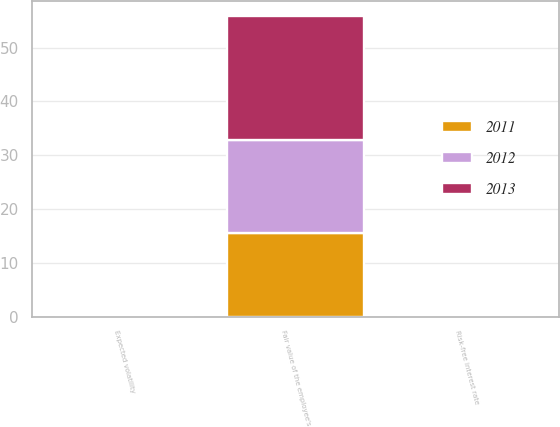Convert chart to OTSL. <chart><loc_0><loc_0><loc_500><loc_500><stacked_bar_chart><ecel><fcel>Fair value of the employee's<fcel>Risk-free interest rate<fcel>Expected volatility<nl><fcel>2012<fcel>17.22<fcel>0.1<fcel>0.2<nl><fcel>2013<fcel>23.02<fcel>0.1<fcel>0.2<nl><fcel>2011<fcel>15.58<fcel>0.1<fcel>0.2<nl></chart> 